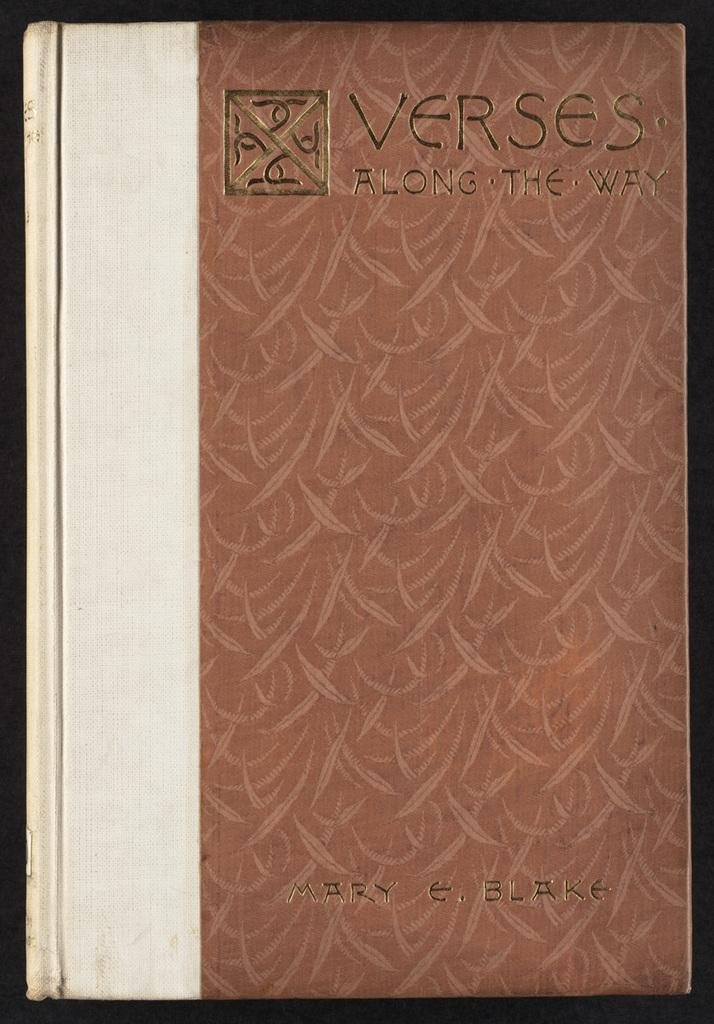<image>
Share a concise interpretation of the image provided. A brown and beige book titled Verses is on a black surface. 